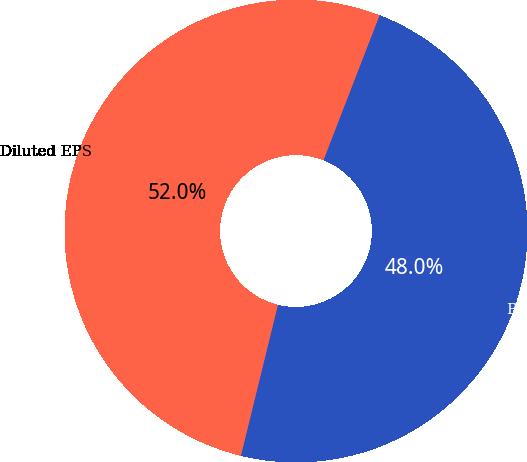<chart> <loc_0><loc_0><loc_500><loc_500><pie_chart><fcel>Basic EPS<fcel>Diluted EPS<nl><fcel>47.95%<fcel>52.05%<nl></chart> 